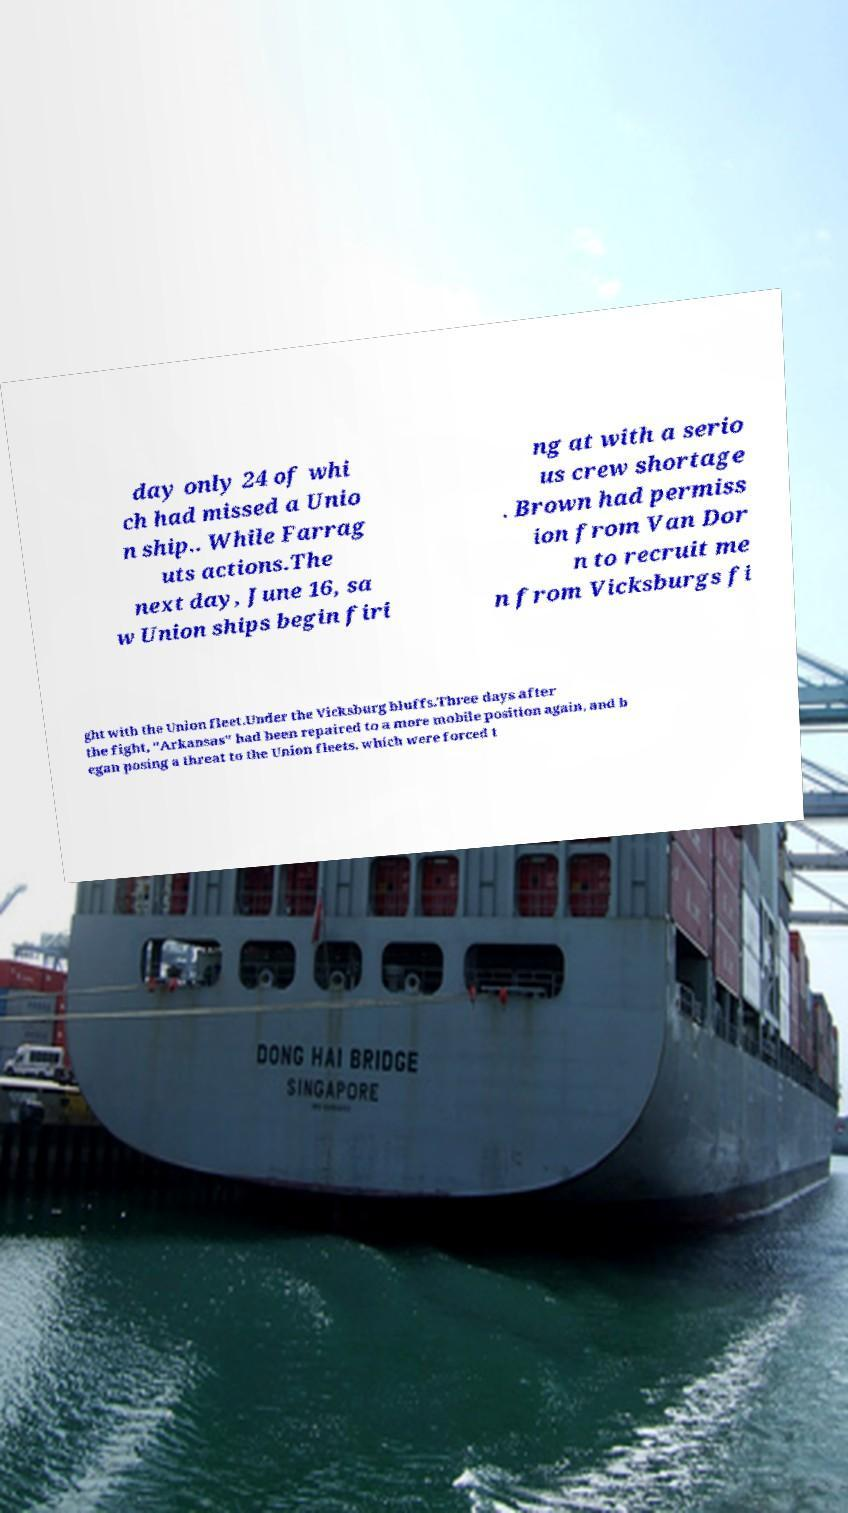Can you read and provide the text displayed in the image?This photo seems to have some interesting text. Can you extract and type it out for me? day only 24 of whi ch had missed a Unio n ship.. While Farrag uts actions.The next day, June 16, sa w Union ships begin firi ng at with a serio us crew shortage . Brown had permiss ion from Van Dor n to recruit me n from Vicksburgs fi ght with the Union fleet.Under the Vicksburg bluffs.Three days after the fight, "Arkansas" had been repaired to a more mobile position again, and b egan posing a threat to the Union fleets, which were forced t 